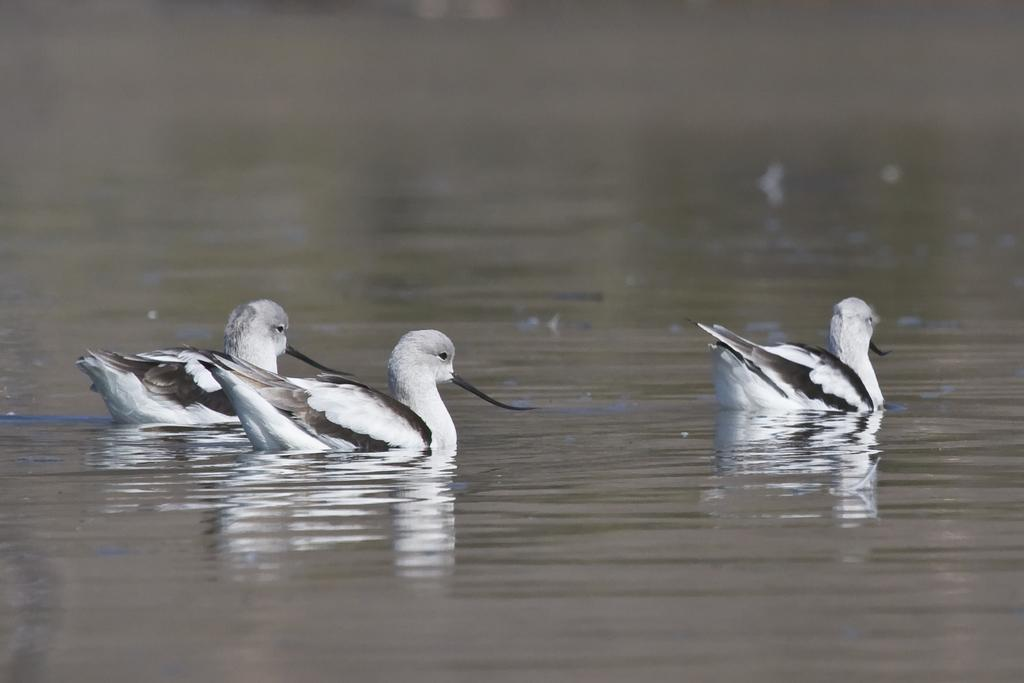How many birds are visible in the image? There are three birds in the image. Where are the birds located in the image? The birds are in the water. Can you describe the possible location where the image was taken? The image may have been taken at a lake. What type of boundary can be seen in the image? There is no boundary visible in the image; it features three birds in the water. What emotion do the birds seem to be expressing in the image? The birds' emotions cannot be determined from the image, as they are not human and do not express emotions in the same way. 